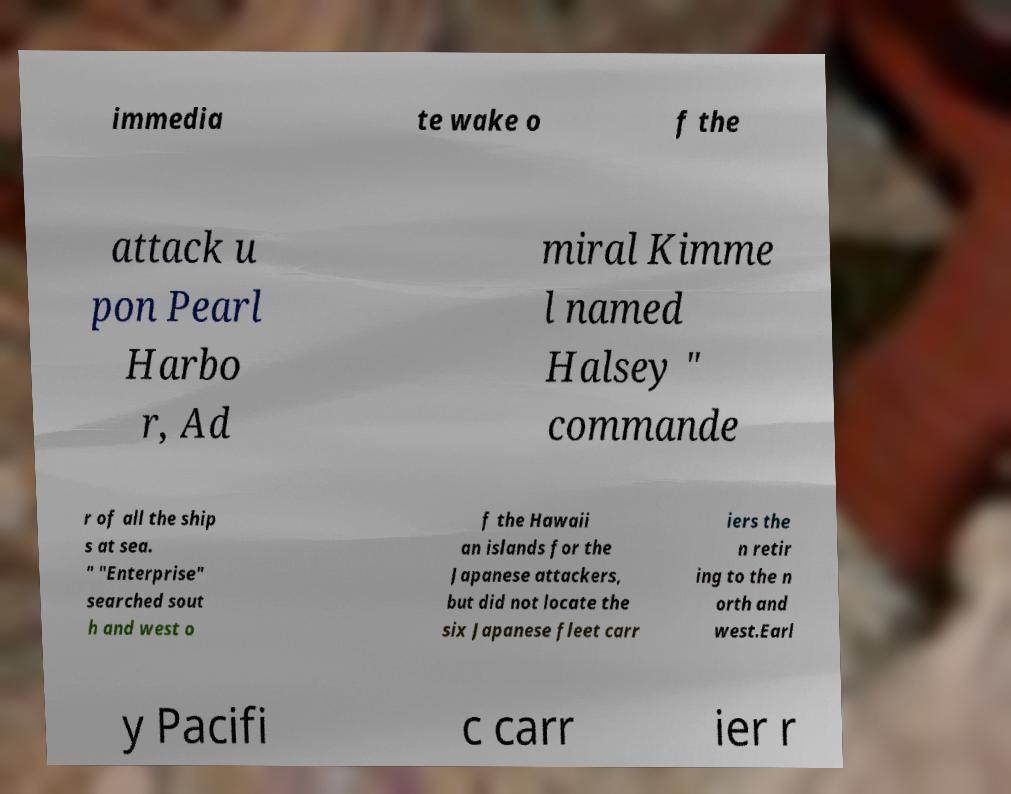Could you extract and type out the text from this image? immedia te wake o f the attack u pon Pearl Harbo r, Ad miral Kimme l named Halsey " commande r of all the ship s at sea. " "Enterprise" searched sout h and west o f the Hawaii an islands for the Japanese attackers, but did not locate the six Japanese fleet carr iers the n retir ing to the n orth and west.Earl y Pacifi c carr ier r 